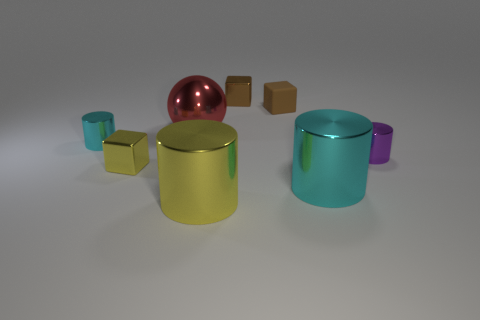Can you describe the texture and material properties of the objects? Certainly! The objects display a variety of textures and material properties. The spherical object has a glossy, reflective finish indicative of a metal or glass material. The cylindrical objects possess a metallic sheen with a smooth finish, suggesting they might be anodized aluminum. Lastly, the small cubes look matte, with a texture that could be associated with wood or a wood-like material. 